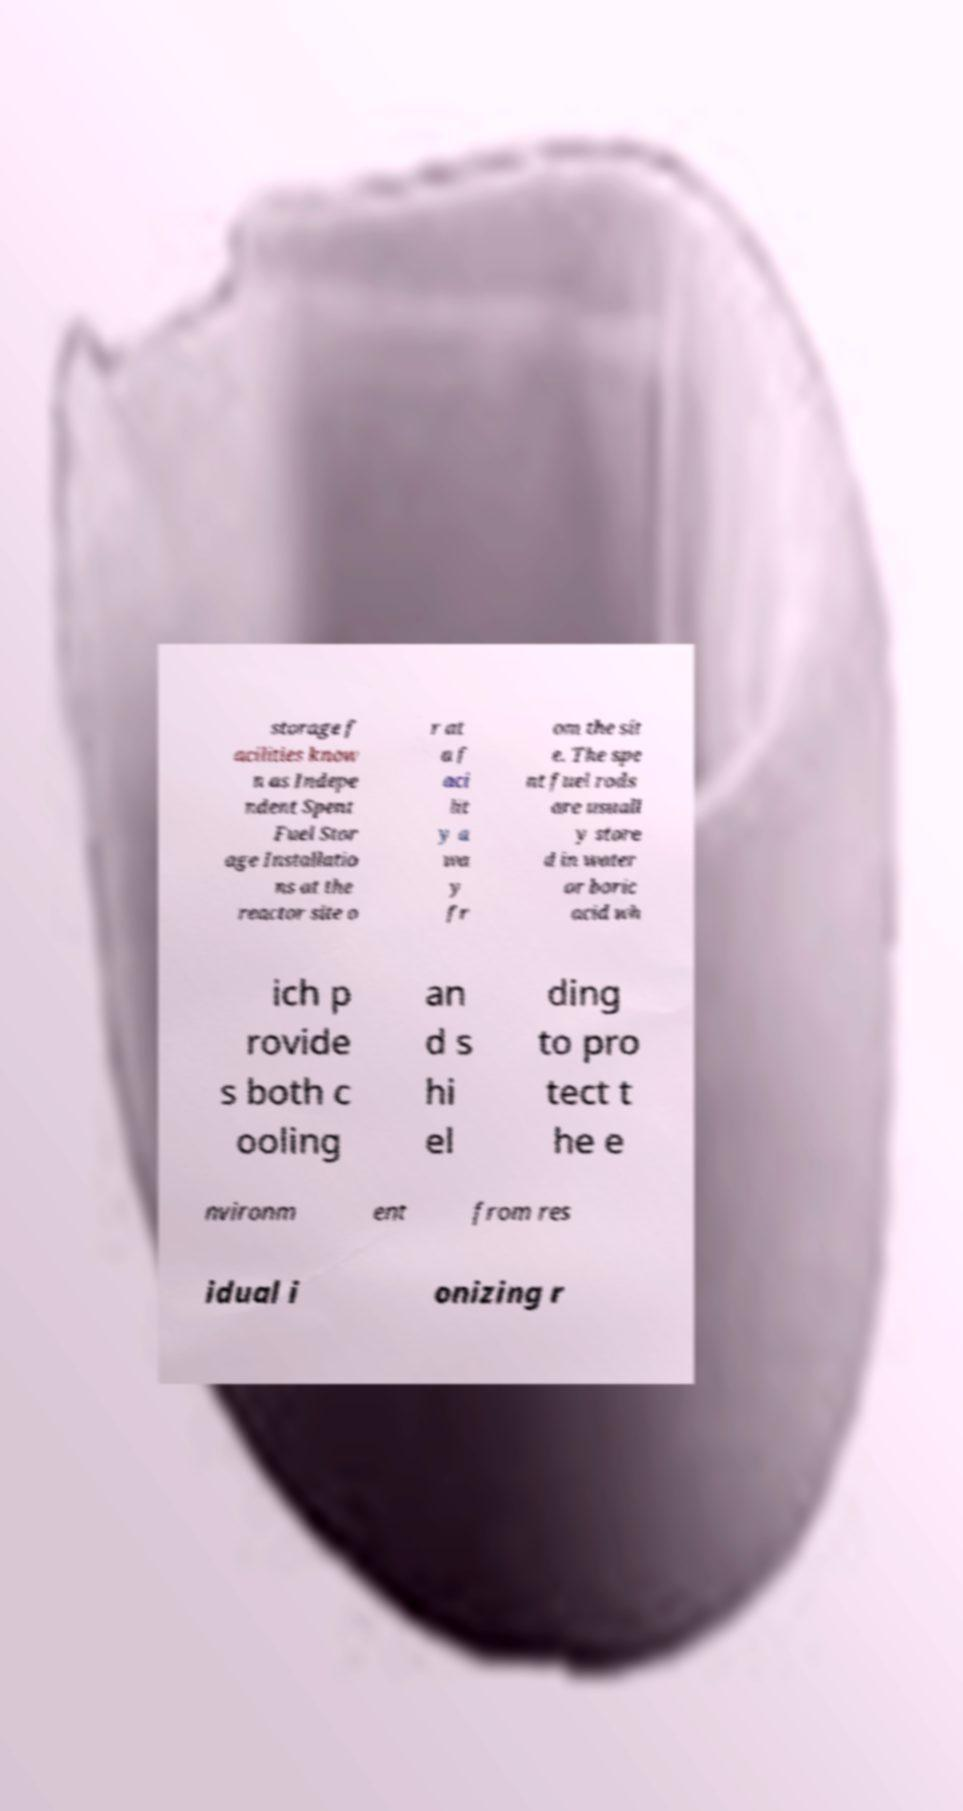Please identify and transcribe the text found in this image. storage f acilities know n as Indepe ndent Spent Fuel Stor age Installatio ns at the reactor site o r at a f aci lit y a wa y fr om the sit e. The spe nt fuel rods are usuall y store d in water or boric acid wh ich p rovide s both c ooling an d s hi el ding to pro tect t he e nvironm ent from res idual i onizing r 